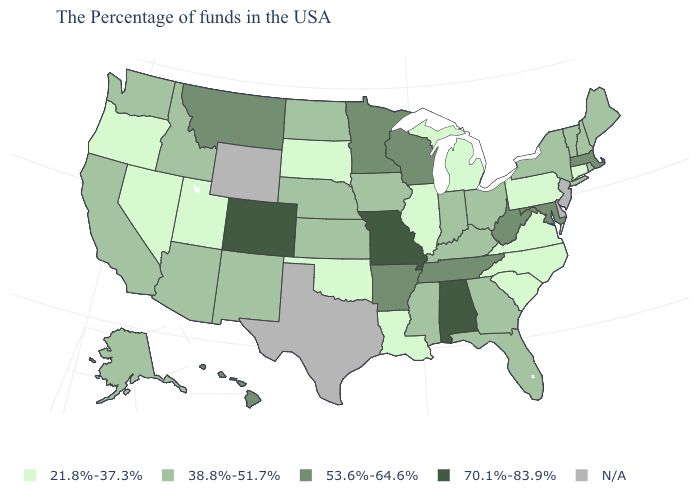How many symbols are there in the legend?
Short answer required. 5. What is the value of West Virginia?
Quick response, please. 53.6%-64.6%. Name the states that have a value in the range N/A?
Short answer required. New Jersey, Delaware, Texas, Wyoming. What is the value of New Jersey?
Answer briefly. N/A. What is the highest value in the USA?
Answer briefly. 70.1%-83.9%. Name the states that have a value in the range 53.6%-64.6%?
Answer briefly. Massachusetts, Maryland, West Virginia, Tennessee, Wisconsin, Arkansas, Minnesota, Montana, Hawaii. What is the lowest value in states that border Iowa?
Answer briefly. 21.8%-37.3%. Which states have the lowest value in the South?
Write a very short answer. Virginia, North Carolina, South Carolina, Louisiana, Oklahoma. Which states have the highest value in the USA?
Quick response, please. Alabama, Missouri, Colorado. Name the states that have a value in the range 21.8%-37.3%?
Write a very short answer. Connecticut, Pennsylvania, Virginia, North Carolina, South Carolina, Michigan, Illinois, Louisiana, Oklahoma, South Dakota, Utah, Nevada, Oregon. Name the states that have a value in the range N/A?
Give a very brief answer. New Jersey, Delaware, Texas, Wyoming. What is the value of Alaska?
Be succinct. 38.8%-51.7%. Name the states that have a value in the range 53.6%-64.6%?
Keep it brief. Massachusetts, Maryland, West Virginia, Tennessee, Wisconsin, Arkansas, Minnesota, Montana, Hawaii. Does Pennsylvania have the lowest value in the Northeast?
Short answer required. Yes. Does the first symbol in the legend represent the smallest category?
Write a very short answer. Yes. 